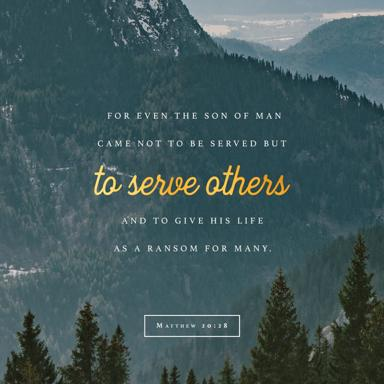Could the choice of typography and design elements in the image influence the interpretation of the quote? Absolutely, the elegant and serene typography along with the tranquil background in the image could serve to evoke a sense of peace and contemplation. These design elements can enhance the spiritual and introspective qualities of the quote, making its message more resonant and uplifting to the viewer. 